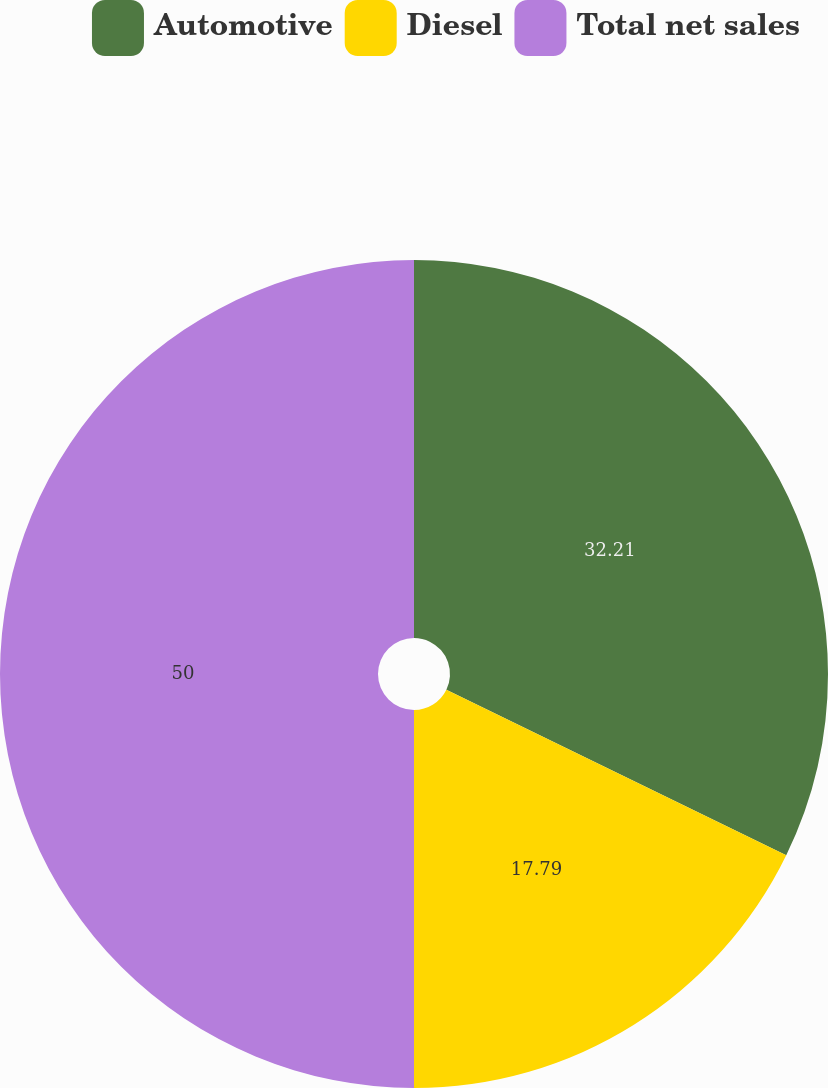Convert chart. <chart><loc_0><loc_0><loc_500><loc_500><pie_chart><fcel>Automotive<fcel>Diesel<fcel>Total net sales<nl><fcel>32.21%<fcel>17.79%<fcel>50.0%<nl></chart> 